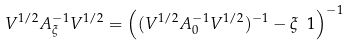<formula> <loc_0><loc_0><loc_500><loc_500>V ^ { 1 / 2 } A _ { \xi } ^ { - 1 } V ^ { 1 / 2 } = \left ( ( V ^ { 1 / 2 } A _ { 0 } ^ { - 1 } V ^ { 1 / 2 } ) ^ { - 1 } - \xi \ 1 \right ) ^ { - 1 }</formula> 